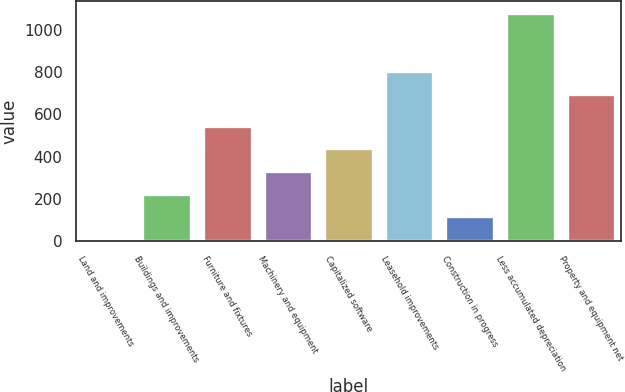Convert chart. <chart><loc_0><loc_0><loc_500><loc_500><bar_chart><fcel>Land and improvements<fcel>Buildings and improvements<fcel>Furniture and fixtures<fcel>Machinery and equipment<fcel>Capitalized software<fcel>Leasehold improvements<fcel>Construction in progress<fcel>Less accumulated depreciation<fcel>Property and equipment net<nl><fcel>9.9<fcel>224.58<fcel>546.6<fcel>331.92<fcel>439.26<fcel>804.54<fcel>117.24<fcel>1083.3<fcel>697.2<nl></chart> 